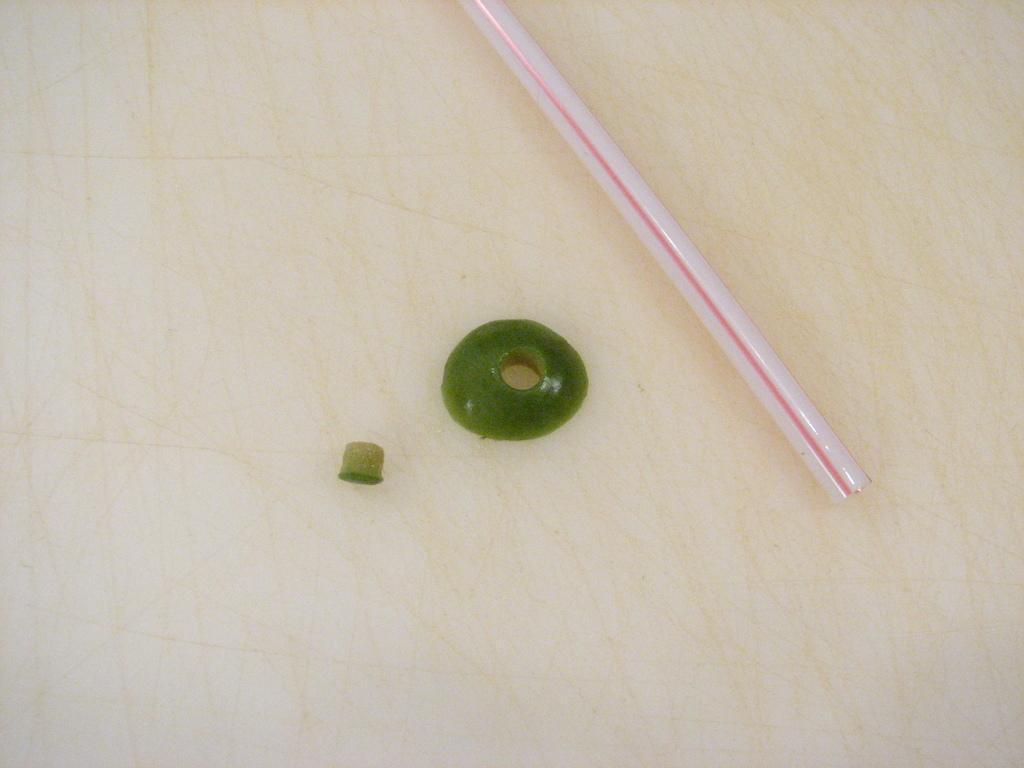Can you describe this image briefly? In this image we can see a straw and green color objects are placed on the floor. 